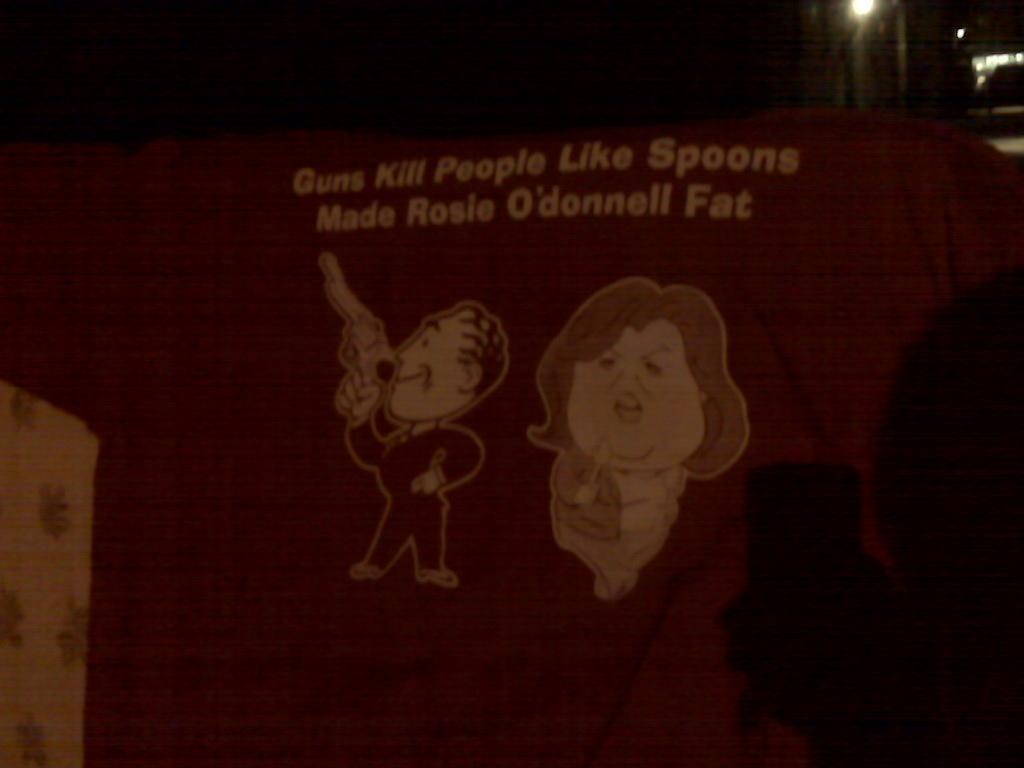How would you summarize this image in a sentence or two? In the picture there are two animated images and above them there is some quotation written on a red background. 